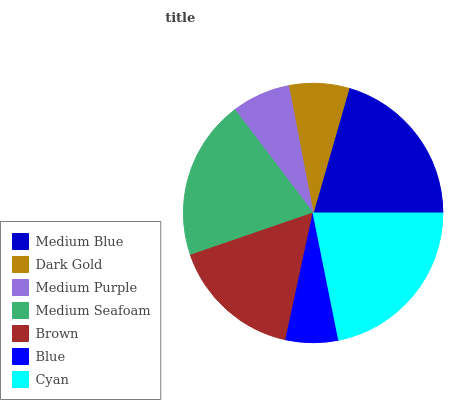Is Blue the minimum?
Answer yes or no. Yes. Is Cyan the maximum?
Answer yes or no. Yes. Is Dark Gold the minimum?
Answer yes or no. No. Is Dark Gold the maximum?
Answer yes or no. No. Is Medium Blue greater than Dark Gold?
Answer yes or no. Yes. Is Dark Gold less than Medium Blue?
Answer yes or no. Yes. Is Dark Gold greater than Medium Blue?
Answer yes or no. No. Is Medium Blue less than Dark Gold?
Answer yes or no. No. Is Brown the high median?
Answer yes or no. Yes. Is Brown the low median?
Answer yes or no. Yes. Is Dark Gold the high median?
Answer yes or no. No. Is Medium Purple the low median?
Answer yes or no. No. 